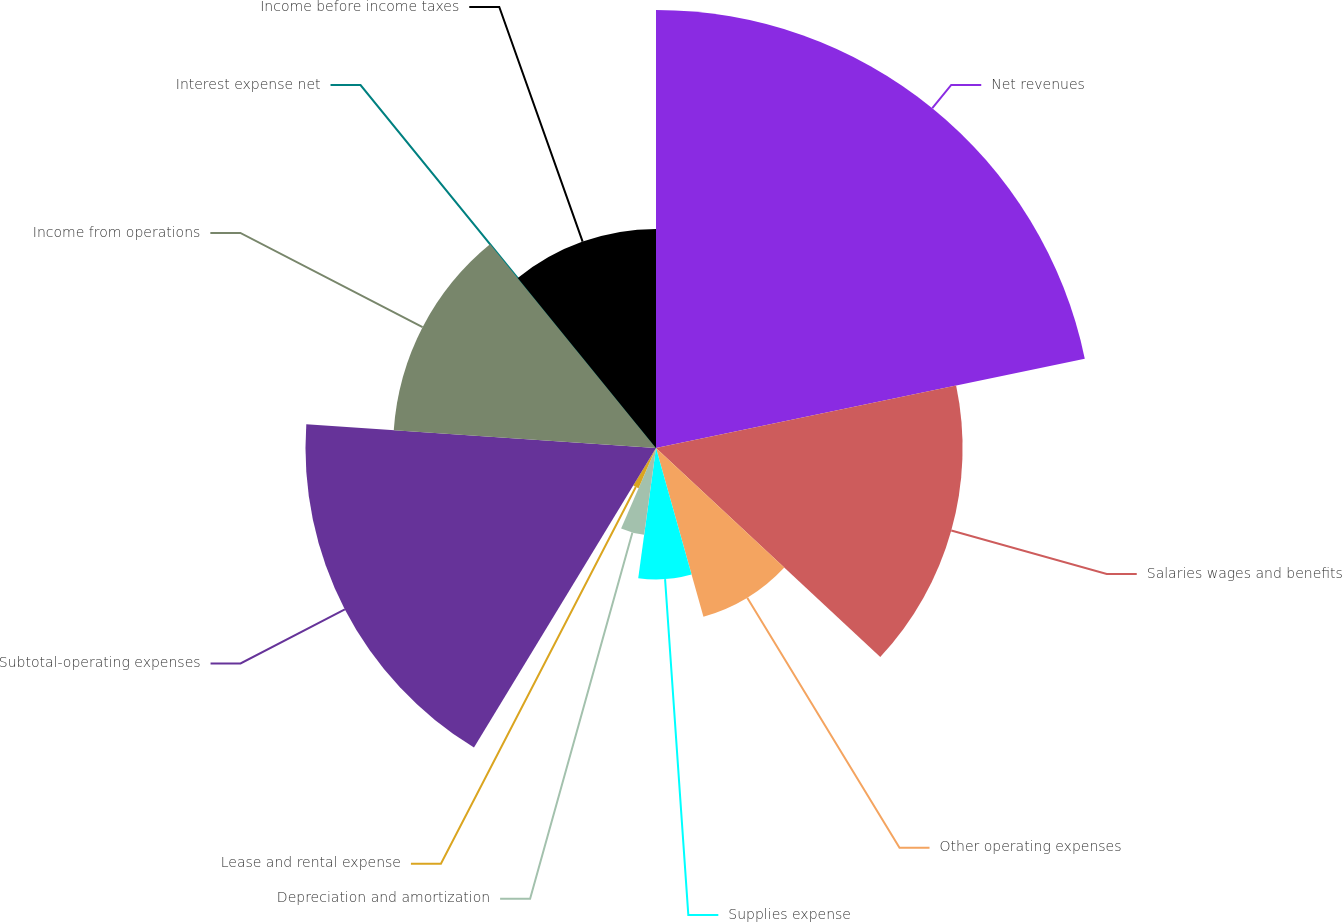<chart> <loc_0><loc_0><loc_500><loc_500><pie_chart><fcel>Net revenues<fcel>Salaries wages and benefits<fcel>Other operating expenses<fcel>Supplies expense<fcel>Depreciation and amortization<fcel>Lease and rental expense<fcel>Subtotal-operating expenses<fcel>Income from operations<fcel>Interest expense net<fcel>Income before income taxes<nl><fcel>21.73%<fcel>15.21%<fcel>8.7%<fcel>6.52%<fcel>4.35%<fcel>2.18%<fcel>17.39%<fcel>13.04%<fcel>0.01%<fcel>10.87%<nl></chart> 